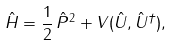<formula> <loc_0><loc_0><loc_500><loc_500>\hat { H } = \frac { 1 } { 2 } \, \hat { P } ^ { 2 } + V ( \hat { U } , \hat { U } ^ { \dagger } ) ,</formula> 